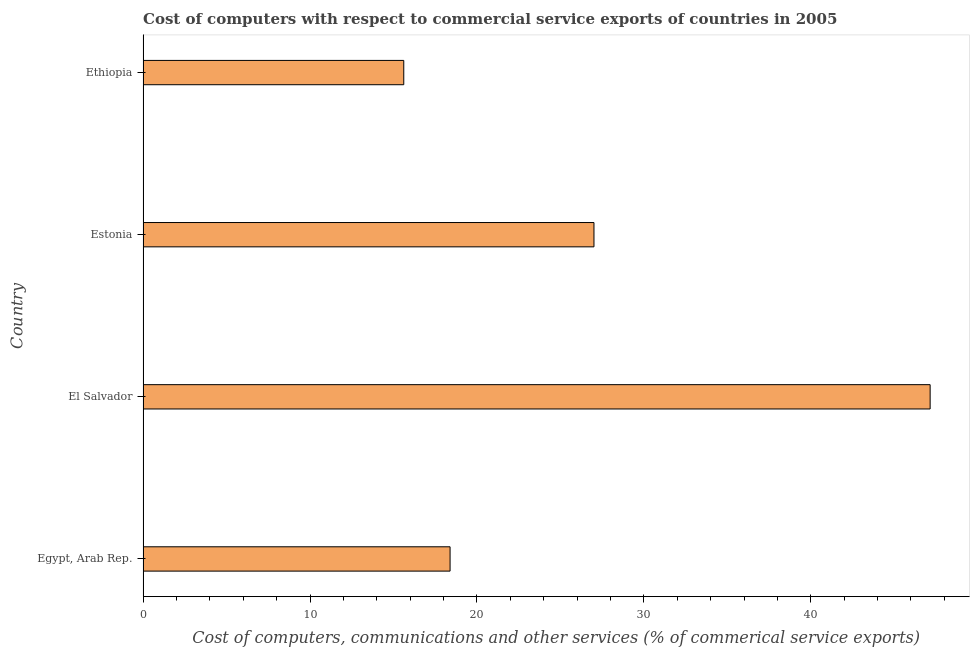Does the graph contain grids?
Your response must be concise. No. What is the title of the graph?
Your response must be concise. Cost of computers with respect to commercial service exports of countries in 2005. What is the label or title of the X-axis?
Provide a short and direct response. Cost of computers, communications and other services (% of commerical service exports). What is the  computer and other services in Egypt, Arab Rep.?
Offer a very short reply. 18.39. Across all countries, what is the maximum  computer and other services?
Provide a succinct answer. 47.15. Across all countries, what is the minimum cost of communications?
Make the answer very short. 15.62. In which country was the  computer and other services maximum?
Ensure brevity in your answer.  El Salvador. In which country was the  computer and other services minimum?
Make the answer very short. Ethiopia. What is the sum of the cost of communications?
Make the answer very short. 108.17. What is the difference between the  computer and other services in Egypt, Arab Rep. and Ethiopia?
Provide a succinct answer. 2.77. What is the average  computer and other services per country?
Keep it short and to the point. 27.04. What is the median  computer and other services?
Your response must be concise. 22.7. In how many countries, is the  computer and other services greater than 38 %?
Your answer should be very brief. 1. What is the ratio of the cost of communications in El Salvador to that in Estonia?
Make the answer very short. 1.75. Is the cost of communications in Egypt, Arab Rep. less than that in El Salvador?
Offer a terse response. Yes. Is the difference between the  computer and other services in Estonia and Ethiopia greater than the difference between any two countries?
Offer a terse response. No. What is the difference between the highest and the second highest  computer and other services?
Offer a very short reply. 20.14. Is the sum of the  computer and other services in El Salvador and Estonia greater than the maximum  computer and other services across all countries?
Your answer should be very brief. Yes. What is the difference between the highest and the lowest cost of communications?
Make the answer very short. 31.53. In how many countries, is the cost of communications greater than the average cost of communications taken over all countries?
Ensure brevity in your answer.  1. How many bars are there?
Provide a short and direct response. 4. What is the Cost of computers, communications and other services (% of commerical service exports) of Egypt, Arab Rep.?
Offer a terse response. 18.39. What is the Cost of computers, communications and other services (% of commerical service exports) of El Salvador?
Your answer should be very brief. 47.15. What is the Cost of computers, communications and other services (% of commerical service exports) in Estonia?
Keep it short and to the point. 27.01. What is the Cost of computers, communications and other services (% of commerical service exports) in Ethiopia?
Your response must be concise. 15.62. What is the difference between the Cost of computers, communications and other services (% of commerical service exports) in Egypt, Arab Rep. and El Salvador?
Provide a succinct answer. -28.76. What is the difference between the Cost of computers, communications and other services (% of commerical service exports) in Egypt, Arab Rep. and Estonia?
Give a very brief answer. -8.62. What is the difference between the Cost of computers, communications and other services (% of commerical service exports) in Egypt, Arab Rep. and Ethiopia?
Your response must be concise. 2.77. What is the difference between the Cost of computers, communications and other services (% of commerical service exports) in El Salvador and Estonia?
Provide a succinct answer. 20.14. What is the difference between the Cost of computers, communications and other services (% of commerical service exports) in El Salvador and Ethiopia?
Ensure brevity in your answer.  31.53. What is the difference between the Cost of computers, communications and other services (% of commerical service exports) in Estonia and Ethiopia?
Offer a terse response. 11.39. What is the ratio of the Cost of computers, communications and other services (% of commerical service exports) in Egypt, Arab Rep. to that in El Salvador?
Your response must be concise. 0.39. What is the ratio of the Cost of computers, communications and other services (% of commerical service exports) in Egypt, Arab Rep. to that in Estonia?
Provide a succinct answer. 0.68. What is the ratio of the Cost of computers, communications and other services (% of commerical service exports) in Egypt, Arab Rep. to that in Ethiopia?
Your response must be concise. 1.18. What is the ratio of the Cost of computers, communications and other services (% of commerical service exports) in El Salvador to that in Estonia?
Make the answer very short. 1.75. What is the ratio of the Cost of computers, communications and other services (% of commerical service exports) in El Salvador to that in Ethiopia?
Your response must be concise. 3.02. What is the ratio of the Cost of computers, communications and other services (% of commerical service exports) in Estonia to that in Ethiopia?
Your response must be concise. 1.73. 